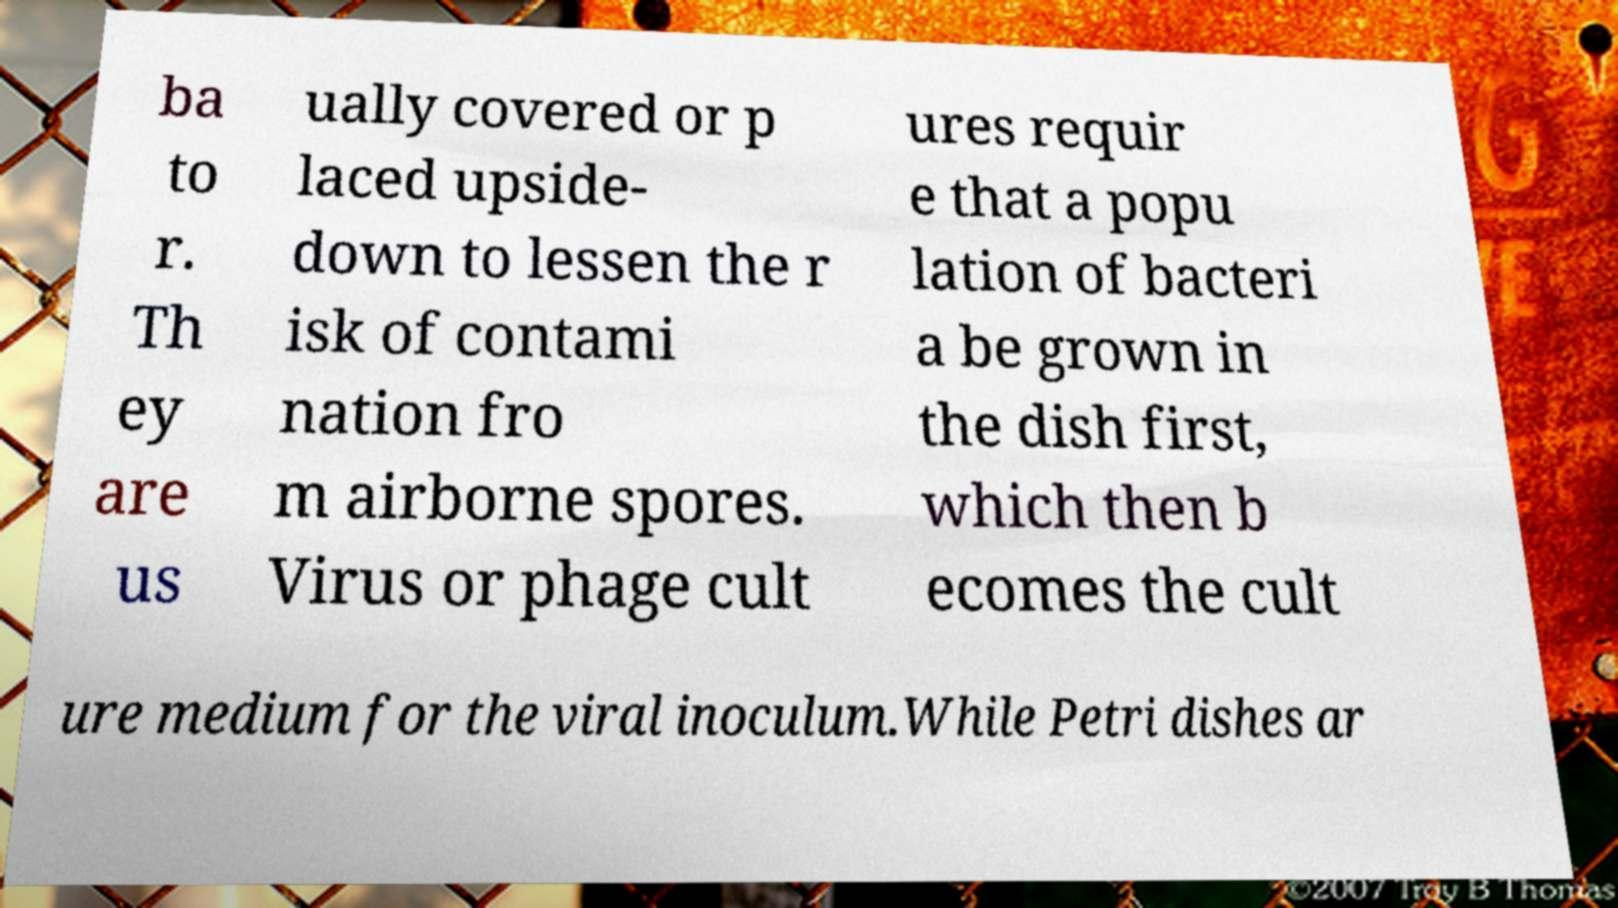I need the written content from this picture converted into text. Can you do that? ba to r. Th ey are us ually covered or p laced upside- down to lessen the r isk of contami nation fro m airborne spores. Virus or phage cult ures requir e that a popu lation of bacteri a be grown in the dish first, which then b ecomes the cult ure medium for the viral inoculum.While Petri dishes ar 